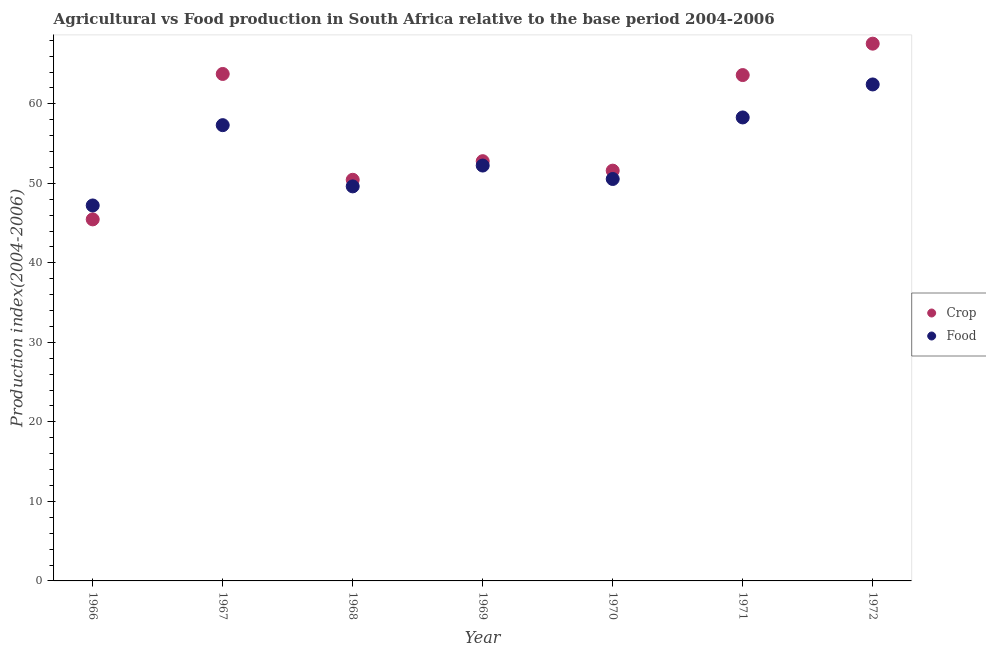How many different coloured dotlines are there?
Your response must be concise. 2. Is the number of dotlines equal to the number of legend labels?
Make the answer very short. Yes. What is the crop production index in 1971?
Your answer should be very brief. 63.62. Across all years, what is the maximum crop production index?
Provide a short and direct response. 67.57. Across all years, what is the minimum food production index?
Provide a short and direct response. 47.22. In which year was the crop production index maximum?
Provide a succinct answer. 1972. In which year was the food production index minimum?
Ensure brevity in your answer.  1966. What is the total crop production index in the graph?
Provide a short and direct response. 395.26. What is the difference between the crop production index in 1966 and that in 1972?
Provide a short and direct response. -22.1. What is the difference between the food production index in 1968 and the crop production index in 1971?
Provide a short and direct response. -14. What is the average crop production index per year?
Offer a very short reply. 56.47. In the year 1969, what is the difference between the food production index and crop production index?
Provide a short and direct response. -0.55. In how many years, is the food production index greater than 6?
Your answer should be compact. 7. What is the ratio of the crop production index in 1967 to that in 1969?
Make the answer very short. 1.21. Is the difference between the crop production index in 1966 and 1972 greater than the difference between the food production index in 1966 and 1972?
Keep it short and to the point. No. What is the difference between the highest and the second highest crop production index?
Your answer should be very brief. 3.81. What is the difference between the highest and the lowest food production index?
Keep it short and to the point. 15.22. How many years are there in the graph?
Keep it short and to the point. 7. What is the difference between two consecutive major ticks on the Y-axis?
Your answer should be very brief. 10. Does the graph contain grids?
Provide a short and direct response. No. Where does the legend appear in the graph?
Provide a succinct answer. Center right. How are the legend labels stacked?
Provide a succinct answer. Vertical. What is the title of the graph?
Give a very brief answer. Agricultural vs Food production in South Africa relative to the base period 2004-2006. What is the label or title of the X-axis?
Ensure brevity in your answer.  Year. What is the label or title of the Y-axis?
Offer a very short reply. Production index(2004-2006). What is the Production index(2004-2006) of Crop in 1966?
Offer a terse response. 45.47. What is the Production index(2004-2006) in Food in 1966?
Your response must be concise. 47.22. What is the Production index(2004-2006) in Crop in 1967?
Your response must be concise. 63.76. What is the Production index(2004-2006) of Food in 1967?
Ensure brevity in your answer.  57.32. What is the Production index(2004-2006) of Crop in 1968?
Your answer should be compact. 50.45. What is the Production index(2004-2006) in Food in 1968?
Provide a succinct answer. 49.62. What is the Production index(2004-2006) in Crop in 1969?
Your answer should be compact. 52.79. What is the Production index(2004-2006) in Food in 1969?
Your response must be concise. 52.24. What is the Production index(2004-2006) in Crop in 1970?
Ensure brevity in your answer.  51.6. What is the Production index(2004-2006) of Food in 1970?
Offer a terse response. 50.55. What is the Production index(2004-2006) of Crop in 1971?
Make the answer very short. 63.62. What is the Production index(2004-2006) in Food in 1971?
Offer a very short reply. 58.29. What is the Production index(2004-2006) in Crop in 1972?
Provide a succinct answer. 67.57. What is the Production index(2004-2006) in Food in 1972?
Ensure brevity in your answer.  62.44. Across all years, what is the maximum Production index(2004-2006) of Crop?
Provide a short and direct response. 67.57. Across all years, what is the maximum Production index(2004-2006) of Food?
Provide a short and direct response. 62.44. Across all years, what is the minimum Production index(2004-2006) of Crop?
Ensure brevity in your answer.  45.47. Across all years, what is the minimum Production index(2004-2006) in Food?
Your response must be concise. 47.22. What is the total Production index(2004-2006) of Crop in the graph?
Ensure brevity in your answer.  395.26. What is the total Production index(2004-2006) in Food in the graph?
Keep it short and to the point. 377.68. What is the difference between the Production index(2004-2006) in Crop in 1966 and that in 1967?
Offer a very short reply. -18.29. What is the difference between the Production index(2004-2006) in Food in 1966 and that in 1967?
Offer a terse response. -10.1. What is the difference between the Production index(2004-2006) of Crop in 1966 and that in 1968?
Make the answer very short. -4.98. What is the difference between the Production index(2004-2006) of Crop in 1966 and that in 1969?
Offer a very short reply. -7.32. What is the difference between the Production index(2004-2006) in Food in 1966 and that in 1969?
Make the answer very short. -5.02. What is the difference between the Production index(2004-2006) of Crop in 1966 and that in 1970?
Provide a succinct answer. -6.13. What is the difference between the Production index(2004-2006) of Food in 1966 and that in 1970?
Your response must be concise. -3.33. What is the difference between the Production index(2004-2006) of Crop in 1966 and that in 1971?
Make the answer very short. -18.15. What is the difference between the Production index(2004-2006) in Food in 1966 and that in 1971?
Provide a short and direct response. -11.07. What is the difference between the Production index(2004-2006) of Crop in 1966 and that in 1972?
Ensure brevity in your answer.  -22.1. What is the difference between the Production index(2004-2006) of Food in 1966 and that in 1972?
Give a very brief answer. -15.22. What is the difference between the Production index(2004-2006) in Crop in 1967 and that in 1968?
Keep it short and to the point. 13.31. What is the difference between the Production index(2004-2006) in Food in 1967 and that in 1968?
Make the answer very short. 7.7. What is the difference between the Production index(2004-2006) in Crop in 1967 and that in 1969?
Offer a terse response. 10.97. What is the difference between the Production index(2004-2006) of Food in 1967 and that in 1969?
Offer a terse response. 5.08. What is the difference between the Production index(2004-2006) of Crop in 1967 and that in 1970?
Provide a succinct answer. 12.16. What is the difference between the Production index(2004-2006) in Food in 1967 and that in 1970?
Give a very brief answer. 6.77. What is the difference between the Production index(2004-2006) of Crop in 1967 and that in 1971?
Your answer should be compact. 0.14. What is the difference between the Production index(2004-2006) in Food in 1967 and that in 1971?
Ensure brevity in your answer.  -0.97. What is the difference between the Production index(2004-2006) in Crop in 1967 and that in 1972?
Make the answer very short. -3.81. What is the difference between the Production index(2004-2006) in Food in 1967 and that in 1972?
Provide a succinct answer. -5.12. What is the difference between the Production index(2004-2006) in Crop in 1968 and that in 1969?
Your answer should be very brief. -2.34. What is the difference between the Production index(2004-2006) of Food in 1968 and that in 1969?
Your answer should be very brief. -2.62. What is the difference between the Production index(2004-2006) of Crop in 1968 and that in 1970?
Provide a short and direct response. -1.15. What is the difference between the Production index(2004-2006) of Food in 1968 and that in 1970?
Your response must be concise. -0.93. What is the difference between the Production index(2004-2006) of Crop in 1968 and that in 1971?
Provide a short and direct response. -13.17. What is the difference between the Production index(2004-2006) in Food in 1968 and that in 1971?
Offer a very short reply. -8.67. What is the difference between the Production index(2004-2006) of Crop in 1968 and that in 1972?
Offer a terse response. -17.12. What is the difference between the Production index(2004-2006) of Food in 1968 and that in 1972?
Keep it short and to the point. -12.82. What is the difference between the Production index(2004-2006) in Crop in 1969 and that in 1970?
Make the answer very short. 1.19. What is the difference between the Production index(2004-2006) of Food in 1969 and that in 1970?
Your answer should be very brief. 1.69. What is the difference between the Production index(2004-2006) in Crop in 1969 and that in 1971?
Provide a succinct answer. -10.83. What is the difference between the Production index(2004-2006) of Food in 1969 and that in 1971?
Ensure brevity in your answer.  -6.05. What is the difference between the Production index(2004-2006) in Crop in 1969 and that in 1972?
Your response must be concise. -14.78. What is the difference between the Production index(2004-2006) of Crop in 1970 and that in 1971?
Offer a terse response. -12.02. What is the difference between the Production index(2004-2006) in Food in 1970 and that in 1971?
Give a very brief answer. -7.74. What is the difference between the Production index(2004-2006) in Crop in 1970 and that in 1972?
Give a very brief answer. -15.97. What is the difference between the Production index(2004-2006) in Food in 1970 and that in 1972?
Give a very brief answer. -11.89. What is the difference between the Production index(2004-2006) of Crop in 1971 and that in 1972?
Make the answer very short. -3.95. What is the difference between the Production index(2004-2006) in Food in 1971 and that in 1972?
Make the answer very short. -4.15. What is the difference between the Production index(2004-2006) in Crop in 1966 and the Production index(2004-2006) in Food in 1967?
Provide a short and direct response. -11.85. What is the difference between the Production index(2004-2006) of Crop in 1966 and the Production index(2004-2006) of Food in 1968?
Keep it short and to the point. -4.15. What is the difference between the Production index(2004-2006) in Crop in 1966 and the Production index(2004-2006) in Food in 1969?
Your response must be concise. -6.77. What is the difference between the Production index(2004-2006) in Crop in 1966 and the Production index(2004-2006) in Food in 1970?
Offer a very short reply. -5.08. What is the difference between the Production index(2004-2006) in Crop in 1966 and the Production index(2004-2006) in Food in 1971?
Your answer should be very brief. -12.82. What is the difference between the Production index(2004-2006) of Crop in 1966 and the Production index(2004-2006) of Food in 1972?
Your response must be concise. -16.97. What is the difference between the Production index(2004-2006) in Crop in 1967 and the Production index(2004-2006) in Food in 1968?
Make the answer very short. 14.14. What is the difference between the Production index(2004-2006) in Crop in 1967 and the Production index(2004-2006) in Food in 1969?
Your answer should be compact. 11.52. What is the difference between the Production index(2004-2006) in Crop in 1967 and the Production index(2004-2006) in Food in 1970?
Your answer should be very brief. 13.21. What is the difference between the Production index(2004-2006) in Crop in 1967 and the Production index(2004-2006) in Food in 1971?
Make the answer very short. 5.47. What is the difference between the Production index(2004-2006) of Crop in 1967 and the Production index(2004-2006) of Food in 1972?
Provide a succinct answer. 1.32. What is the difference between the Production index(2004-2006) in Crop in 1968 and the Production index(2004-2006) in Food in 1969?
Ensure brevity in your answer.  -1.79. What is the difference between the Production index(2004-2006) of Crop in 1968 and the Production index(2004-2006) of Food in 1971?
Give a very brief answer. -7.84. What is the difference between the Production index(2004-2006) in Crop in 1968 and the Production index(2004-2006) in Food in 1972?
Provide a succinct answer. -11.99. What is the difference between the Production index(2004-2006) of Crop in 1969 and the Production index(2004-2006) of Food in 1970?
Your response must be concise. 2.24. What is the difference between the Production index(2004-2006) of Crop in 1969 and the Production index(2004-2006) of Food in 1972?
Ensure brevity in your answer.  -9.65. What is the difference between the Production index(2004-2006) in Crop in 1970 and the Production index(2004-2006) in Food in 1971?
Ensure brevity in your answer.  -6.69. What is the difference between the Production index(2004-2006) of Crop in 1970 and the Production index(2004-2006) of Food in 1972?
Your answer should be compact. -10.84. What is the difference between the Production index(2004-2006) in Crop in 1971 and the Production index(2004-2006) in Food in 1972?
Your response must be concise. 1.18. What is the average Production index(2004-2006) of Crop per year?
Provide a succinct answer. 56.47. What is the average Production index(2004-2006) of Food per year?
Keep it short and to the point. 53.95. In the year 1966, what is the difference between the Production index(2004-2006) of Crop and Production index(2004-2006) of Food?
Provide a short and direct response. -1.75. In the year 1967, what is the difference between the Production index(2004-2006) of Crop and Production index(2004-2006) of Food?
Ensure brevity in your answer.  6.44. In the year 1968, what is the difference between the Production index(2004-2006) of Crop and Production index(2004-2006) of Food?
Make the answer very short. 0.83. In the year 1969, what is the difference between the Production index(2004-2006) of Crop and Production index(2004-2006) of Food?
Your answer should be very brief. 0.55. In the year 1970, what is the difference between the Production index(2004-2006) of Crop and Production index(2004-2006) of Food?
Make the answer very short. 1.05. In the year 1971, what is the difference between the Production index(2004-2006) in Crop and Production index(2004-2006) in Food?
Provide a short and direct response. 5.33. In the year 1972, what is the difference between the Production index(2004-2006) of Crop and Production index(2004-2006) of Food?
Give a very brief answer. 5.13. What is the ratio of the Production index(2004-2006) in Crop in 1966 to that in 1967?
Give a very brief answer. 0.71. What is the ratio of the Production index(2004-2006) of Food in 1966 to that in 1967?
Make the answer very short. 0.82. What is the ratio of the Production index(2004-2006) in Crop in 1966 to that in 1968?
Offer a very short reply. 0.9. What is the ratio of the Production index(2004-2006) of Food in 1966 to that in 1968?
Your answer should be very brief. 0.95. What is the ratio of the Production index(2004-2006) in Crop in 1966 to that in 1969?
Give a very brief answer. 0.86. What is the ratio of the Production index(2004-2006) in Food in 1966 to that in 1969?
Ensure brevity in your answer.  0.9. What is the ratio of the Production index(2004-2006) in Crop in 1966 to that in 1970?
Provide a succinct answer. 0.88. What is the ratio of the Production index(2004-2006) of Food in 1966 to that in 1970?
Your response must be concise. 0.93. What is the ratio of the Production index(2004-2006) in Crop in 1966 to that in 1971?
Provide a short and direct response. 0.71. What is the ratio of the Production index(2004-2006) of Food in 1966 to that in 1971?
Your answer should be very brief. 0.81. What is the ratio of the Production index(2004-2006) in Crop in 1966 to that in 1972?
Provide a short and direct response. 0.67. What is the ratio of the Production index(2004-2006) of Food in 1966 to that in 1972?
Ensure brevity in your answer.  0.76. What is the ratio of the Production index(2004-2006) in Crop in 1967 to that in 1968?
Your response must be concise. 1.26. What is the ratio of the Production index(2004-2006) of Food in 1967 to that in 1968?
Offer a terse response. 1.16. What is the ratio of the Production index(2004-2006) in Crop in 1967 to that in 1969?
Ensure brevity in your answer.  1.21. What is the ratio of the Production index(2004-2006) in Food in 1967 to that in 1969?
Keep it short and to the point. 1.1. What is the ratio of the Production index(2004-2006) of Crop in 1967 to that in 1970?
Keep it short and to the point. 1.24. What is the ratio of the Production index(2004-2006) in Food in 1967 to that in 1970?
Make the answer very short. 1.13. What is the ratio of the Production index(2004-2006) in Food in 1967 to that in 1971?
Give a very brief answer. 0.98. What is the ratio of the Production index(2004-2006) of Crop in 1967 to that in 1972?
Keep it short and to the point. 0.94. What is the ratio of the Production index(2004-2006) in Food in 1967 to that in 1972?
Offer a terse response. 0.92. What is the ratio of the Production index(2004-2006) of Crop in 1968 to that in 1969?
Ensure brevity in your answer.  0.96. What is the ratio of the Production index(2004-2006) in Food in 1968 to that in 1969?
Provide a succinct answer. 0.95. What is the ratio of the Production index(2004-2006) in Crop in 1968 to that in 1970?
Your answer should be very brief. 0.98. What is the ratio of the Production index(2004-2006) in Food in 1968 to that in 1970?
Your answer should be very brief. 0.98. What is the ratio of the Production index(2004-2006) of Crop in 1968 to that in 1971?
Give a very brief answer. 0.79. What is the ratio of the Production index(2004-2006) of Food in 1968 to that in 1971?
Your answer should be very brief. 0.85. What is the ratio of the Production index(2004-2006) of Crop in 1968 to that in 1972?
Give a very brief answer. 0.75. What is the ratio of the Production index(2004-2006) in Food in 1968 to that in 1972?
Give a very brief answer. 0.79. What is the ratio of the Production index(2004-2006) in Crop in 1969 to that in 1970?
Offer a terse response. 1.02. What is the ratio of the Production index(2004-2006) in Food in 1969 to that in 1970?
Your answer should be compact. 1.03. What is the ratio of the Production index(2004-2006) in Crop in 1969 to that in 1971?
Keep it short and to the point. 0.83. What is the ratio of the Production index(2004-2006) in Food in 1969 to that in 1971?
Your answer should be very brief. 0.9. What is the ratio of the Production index(2004-2006) of Crop in 1969 to that in 1972?
Provide a short and direct response. 0.78. What is the ratio of the Production index(2004-2006) of Food in 1969 to that in 1972?
Offer a very short reply. 0.84. What is the ratio of the Production index(2004-2006) of Crop in 1970 to that in 1971?
Ensure brevity in your answer.  0.81. What is the ratio of the Production index(2004-2006) of Food in 1970 to that in 1971?
Your answer should be compact. 0.87. What is the ratio of the Production index(2004-2006) in Crop in 1970 to that in 1972?
Offer a very short reply. 0.76. What is the ratio of the Production index(2004-2006) in Food in 1970 to that in 1972?
Give a very brief answer. 0.81. What is the ratio of the Production index(2004-2006) of Crop in 1971 to that in 1972?
Ensure brevity in your answer.  0.94. What is the ratio of the Production index(2004-2006) of Food in 1971 to that in 1972?
Keep it short and to the point. 0.93. What is the difference between the highest and the second highest Production index(2004-2006) in Crop?
Keep it short and to the point. 3.81. What is the difference between the highest and the second highest Production index(2004-2006) in Food?
Your answer should be compact. 4.15. What is the difference between the highest and the lowest Production index(2004-2006) of Crop?
Ensure brevity in your answer.  22.1. What is the difference between the highest and the lowest Production index(2004-2006) of Food?
Offer a terse response. 15.22. 